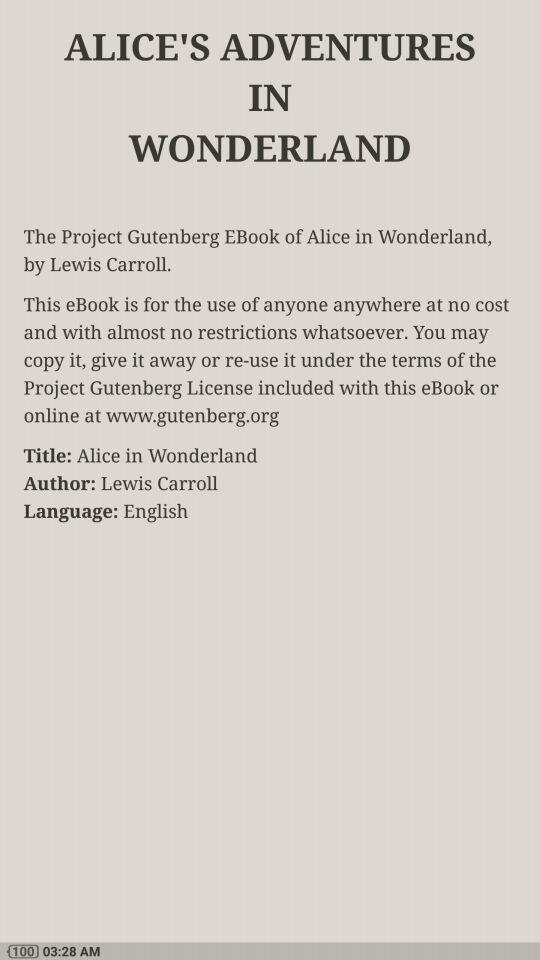What is the title? The title is "Alice in Wonderland". 